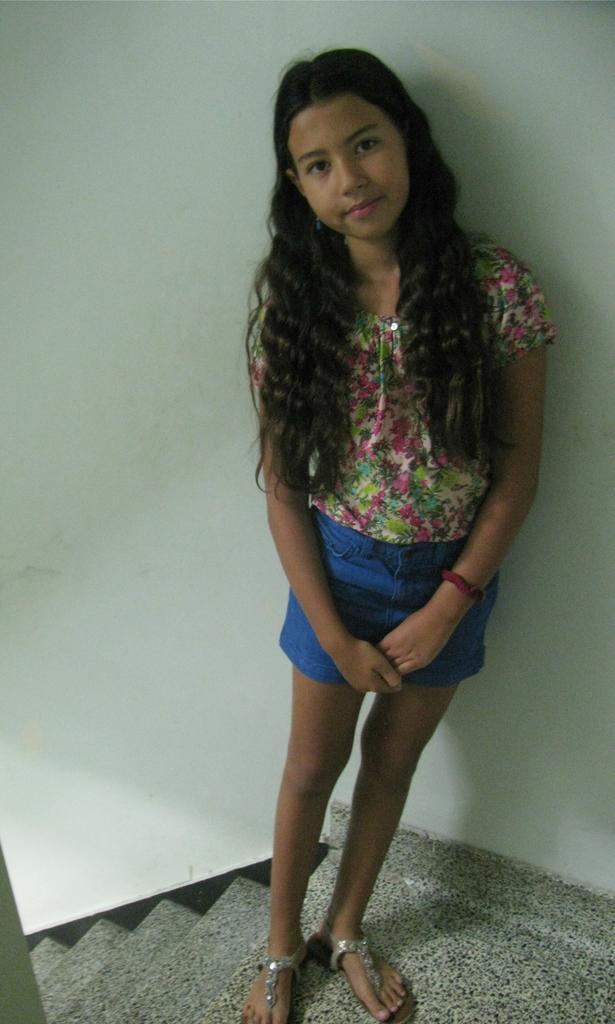Describe this image in one or two sentences. In this picture we can see a girl standing on the floor and smiling, steps and in the background we can see wall. 